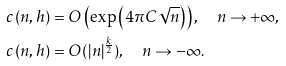Convert formula to latex. <formula><loc_0><loc_0><loc_500><loc_500>c \left ( n , h \right ) & = O \left ( \exp \left ( 4 \pi C \sqrt { n } \right ) \right ) , \quad n \rightarrow + \infty , \\ c \left ( n , h \right ) & = O ( | n | ^ { \frac { k } { 2 } } ) , \quad n \rightarrow - \infty .</formula> 